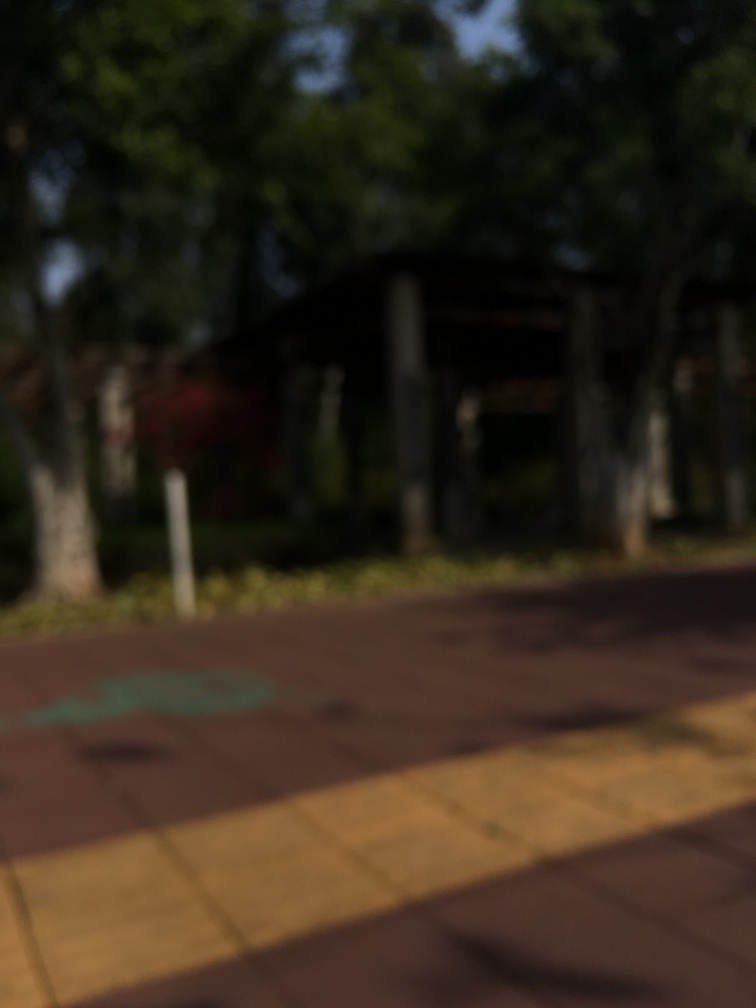Can you describe what might be the cause of the blurriness in this photo? The blurriness in the photo could be due to a number of factors, such as movement either from the camera or the subject during the shot, incorrect focus settings, or even a smudge on the lens. It effectively prevents us from identifying specific elements, like whether there are people or what kinds of plants are in the image. 